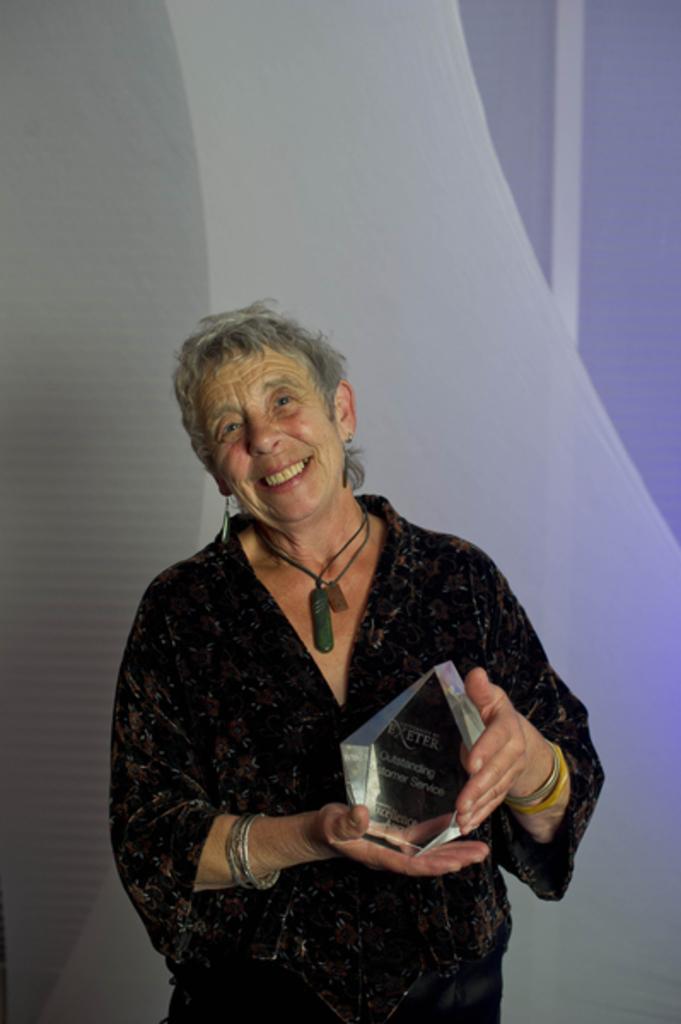Describe this image in one or two sentences. In this picture there is a woman standing and holding the object and there is a text on the object. At the back there is a board. 